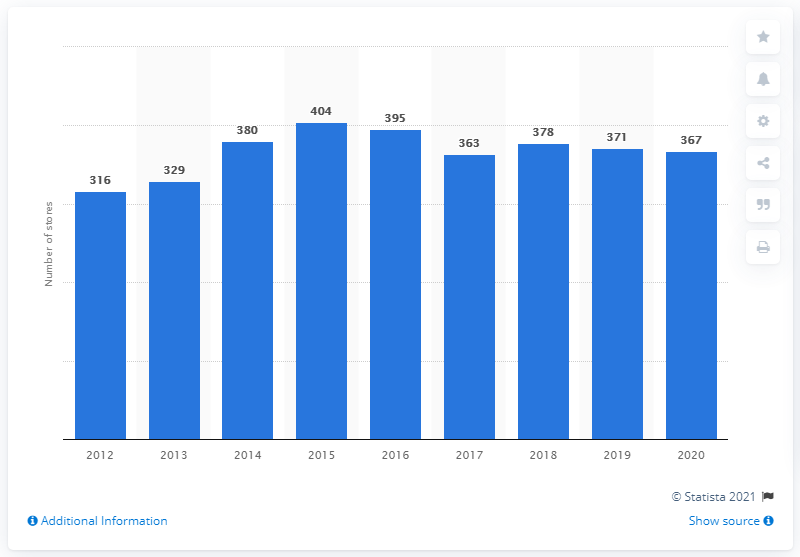Specify some key components in this picture. In the previous year, Walmart had 371 stores. In 2020, Walmart had a total of 367 stores in Chile. 